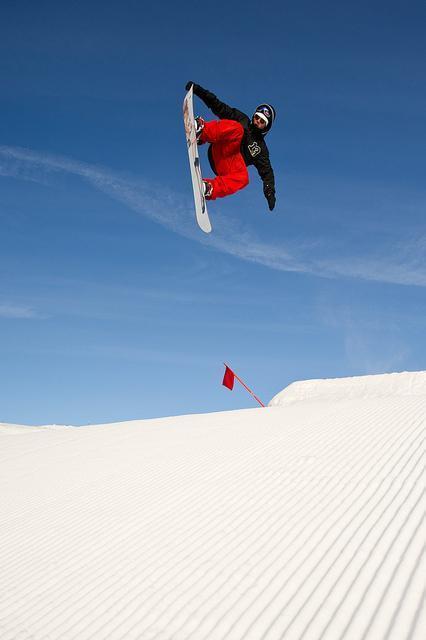How many frisbee in photo?
Give a very brief answer. 0. 